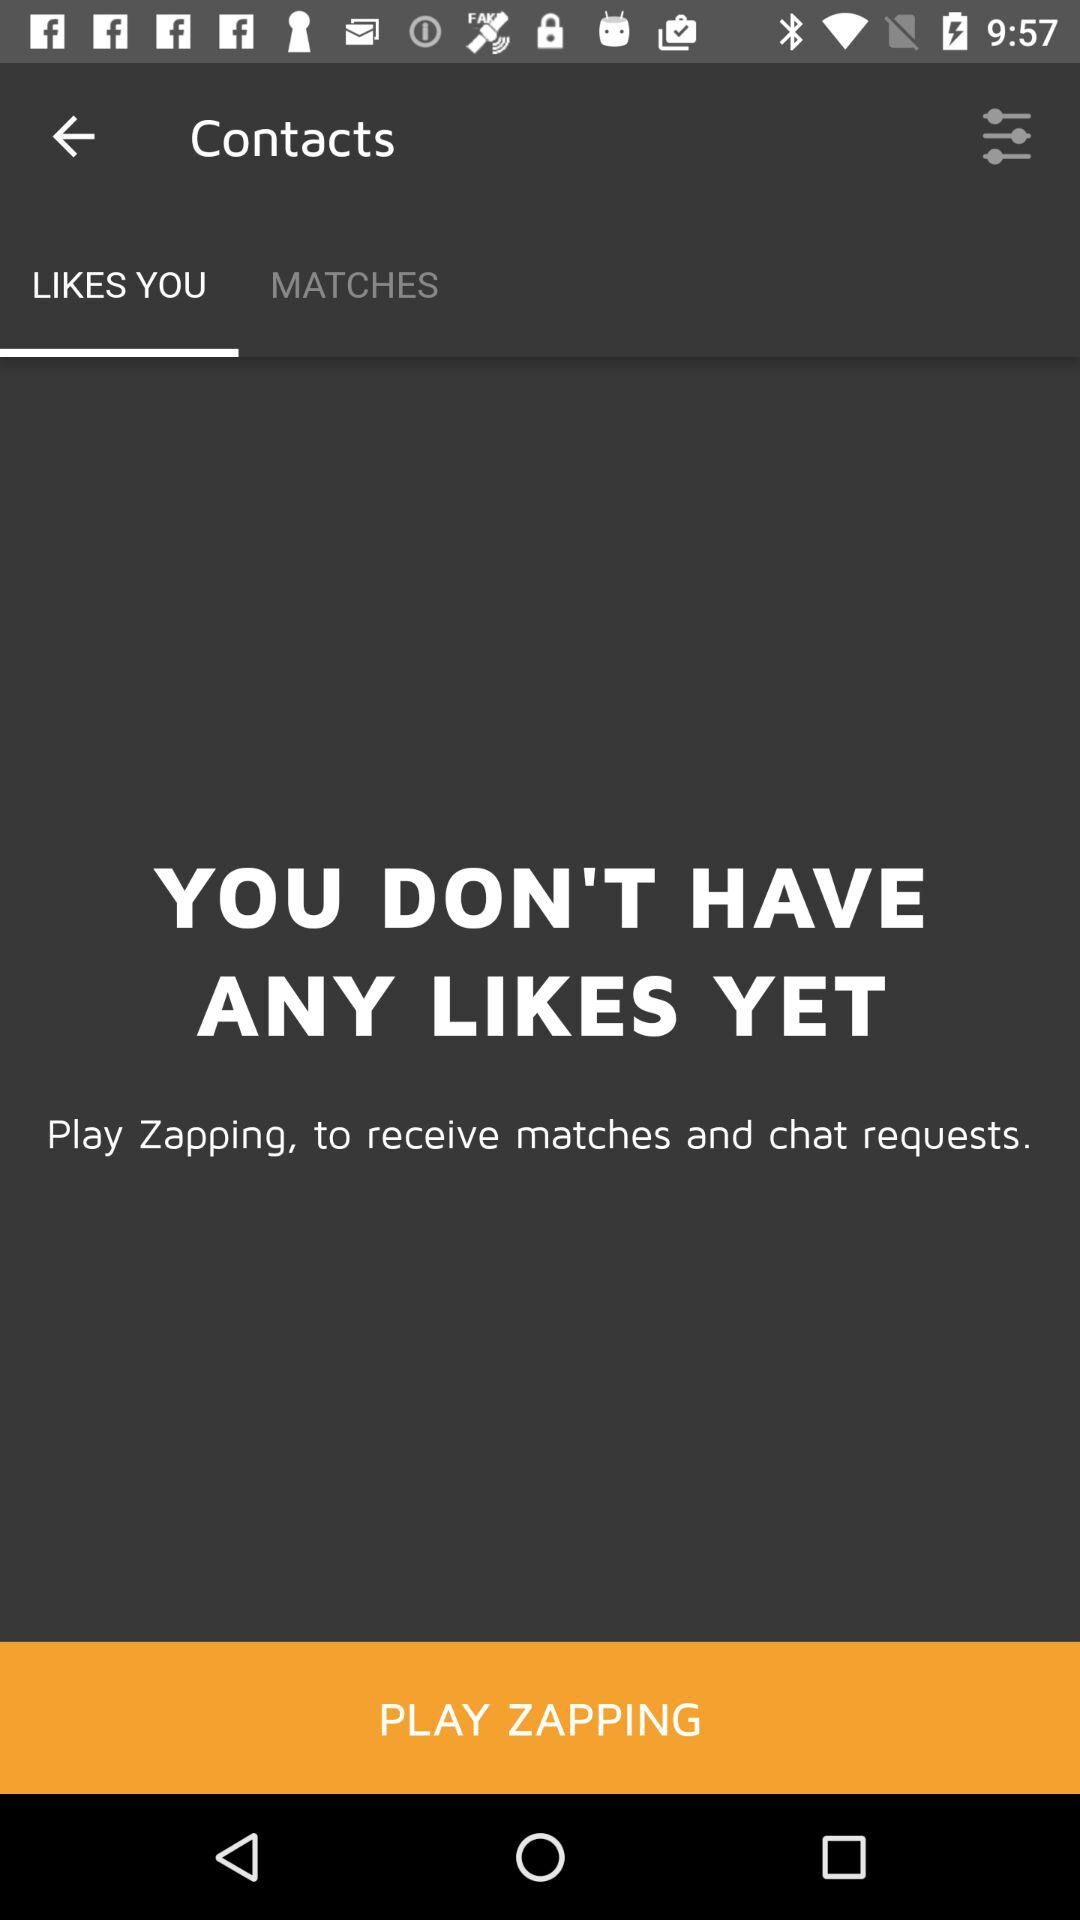Is there any like? You don't have any likes yet. 